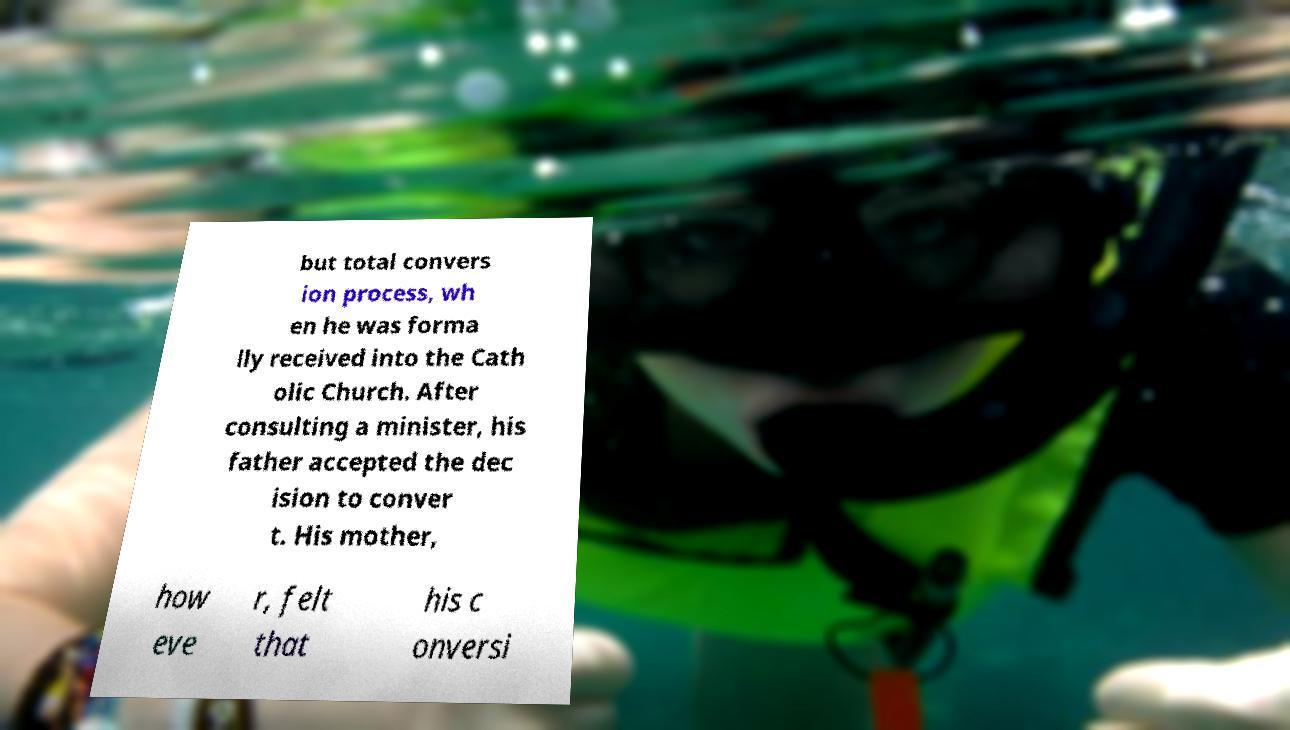For documentation purposes, I need the text within this image transcribed. Could you provide that? but total convers ion process, wh en he was forma lly received into the Cath olic Church. After consulting a minister, his father accepted the dec ision to conver t. His mother, how eve r, felt that his c onversi 